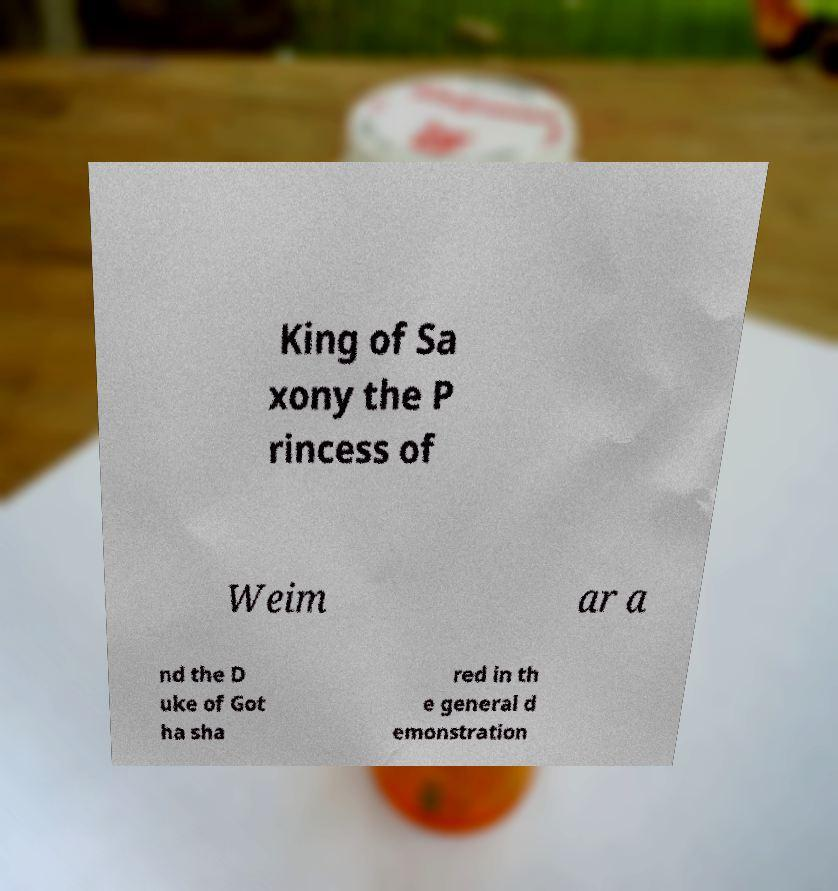Please identify and transcribe the text found in this image. King of Sa xony the P rincess of Weim ar a nd the D uke of Got ha sha red in th e general d emonstration 